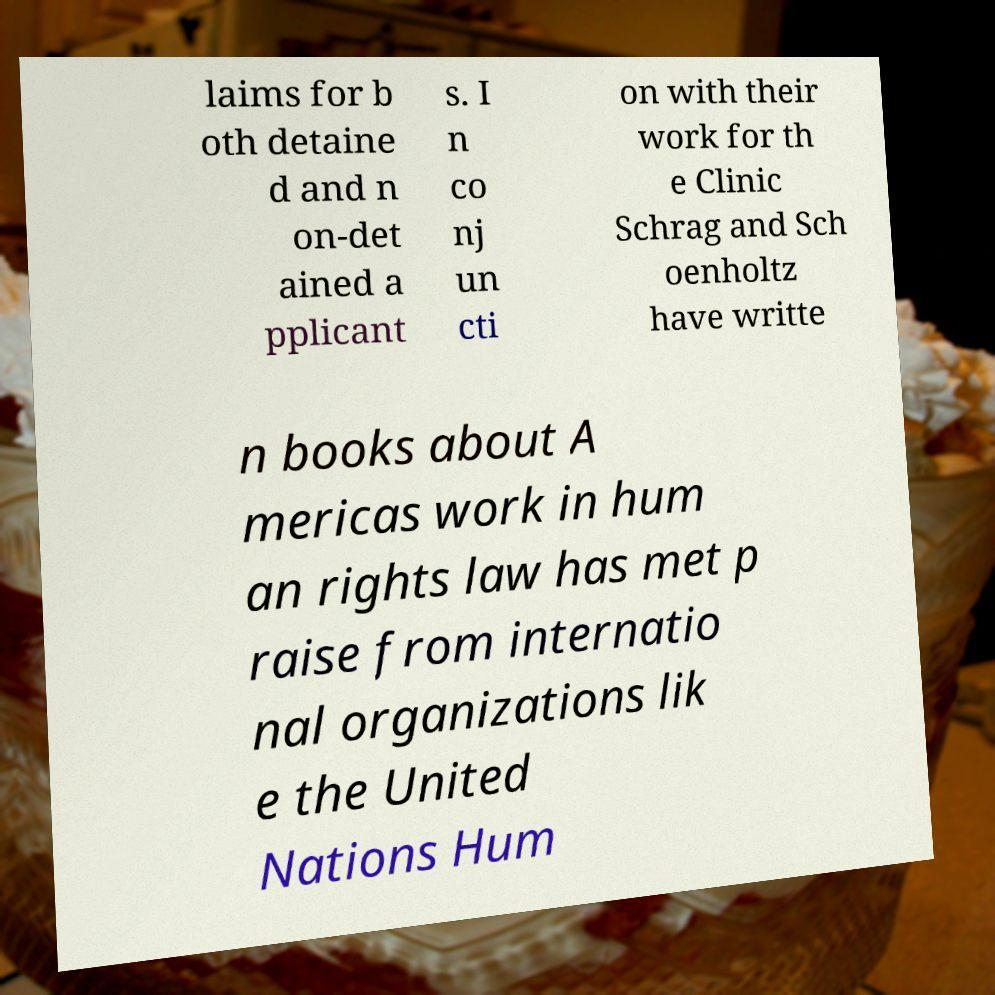Please identify and transcribe the text found in this image. laims for b oth detaine d and n on-det ained a pplicant s. I n co nj un cti on with their work for th e Clinic Schrag and Sch oenholtz have writte n books about A mericas work in hum an rights law has met p raise from internatio nal organizations lik e the United Nations Hum 